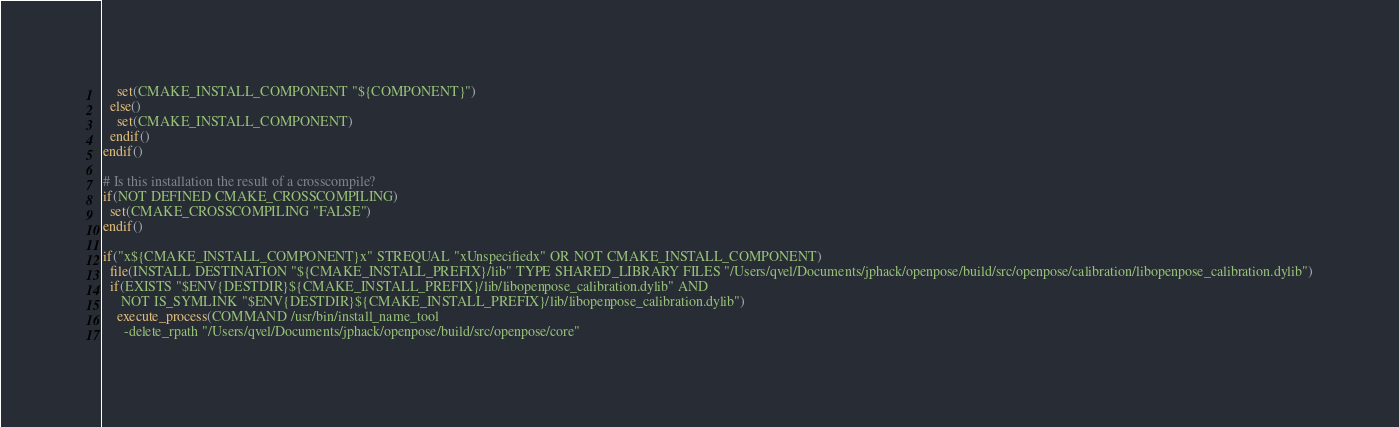<code> <loc_0><loc_0><loc_500><loc_500><_CMake_>    set(CMAKE_INSTALL_COMPONENT "${COMPONENT}")
  else()
    set(CMAKE_INSTALL_COMPONENT)
  endif()
endif()

# Is this installation the result of a crosscompile?
if(NOT DEFINED CMAKE_CROSSCOMPILING)
  set(CMAKE_CROSSCOMPILING "FALSE")
endif()

if("x${CMAKE_INSTALL_COMPONENT}x" STREQUAL "xUnspecifiedx" OR NOT CMAKE_INSTALL_COMPONENT)
  file(INSTALL DESTINATION "${CMAKE_INSTALL_PREFIX}/lib" TYPE SHARED_LIBRARY FILES "/Users/qvel/Documents/jphack/openpose/build/src/openpose/calibration/libopenpose_calibration.dylib")
  if(EXISTS "$ENV{DESTDIR}${CMAKE_INSTALL_PREFIX}/lib/libopenpose_calibration.dylib" AND
     NOT IS_SYMLINK "$ENV{DESTDIR}${CMAKE_INSTALL_PREFIX}/lib/libopenpose_calibration.dylib")
    execute_process(COMMAND /usr/bin/install_name_tool
      -delete_rpath "/Users/qvel/Documents/jphack/openpose/build/src/openpose/core"</code> 